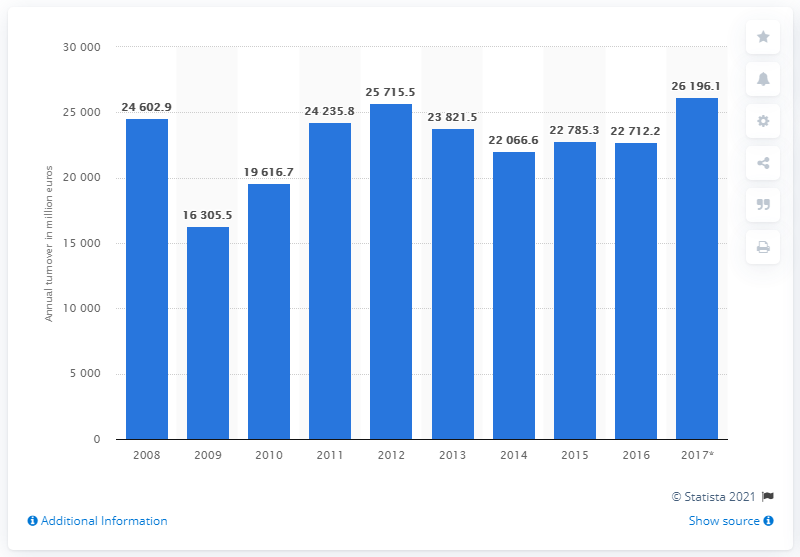Point out several critical features in this image. In 2016, the turnover of Sweden's machinery and equipment industry was 22,712.2 million. 